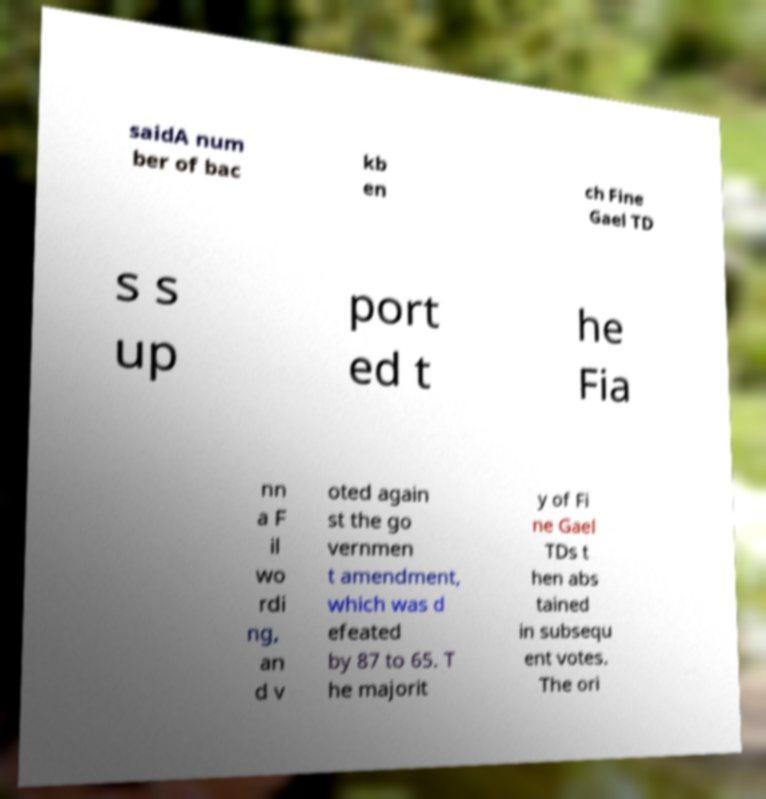Can you read and provide the text displayed in the image?This photo seems to have some interesting text. Can you extract and type it out for me? saidA num ber of bac kb en ch Fine Gael TD s s up port ed t he Fia nn a F il wo rdi ng, an d v oted again st the go vernmen t amendment, which was d efeated by 87 to 65. T he majorit y of Fi ne Gael TDs t hen abs tained in subsequ ent votes. The ori 